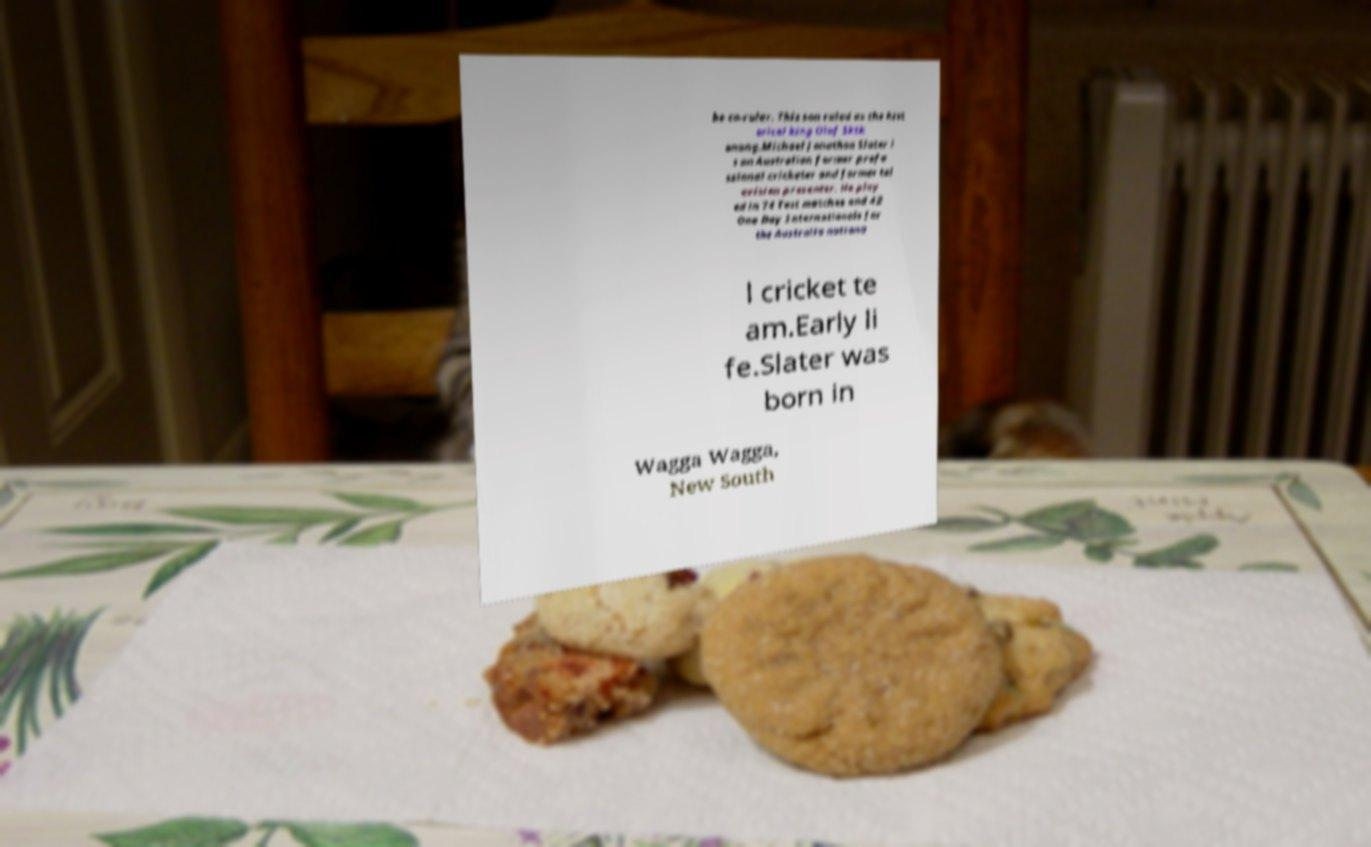Could you assist in decoding the text presented in this image and type it out clearly? be co-ruler. This son ruled as the hist orical king Olof Sktk onung.Michael Jonathon Slater i s an Australian former profe ssional cricketer and former tel evision presenter. He play ed in 74 Test matches and 42 One Day Internationals for the Australia nationa l cricket te am.Early li fe.Slater was born in Wagga Wagga, New South 